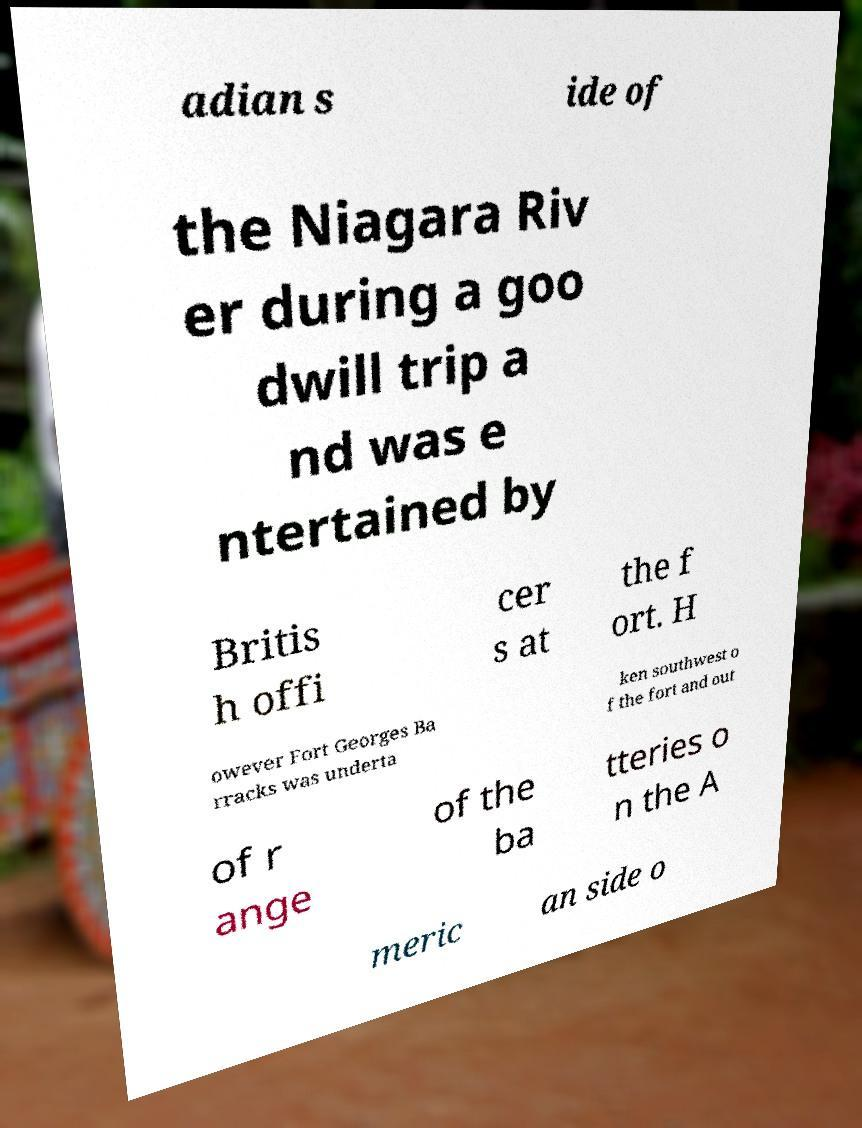For documentation purposes, I need the text within this image transcribed. Could you provide that? adian s ide of the Niagara Riv er during a goo dwill trip a nd was e ntertained by Britis h offi cer s at the f ort. H owever Fort Georges Ba rracks was underta ken southwest o f the fort and out of r ange of the ba tteries o n the A meric an side o 